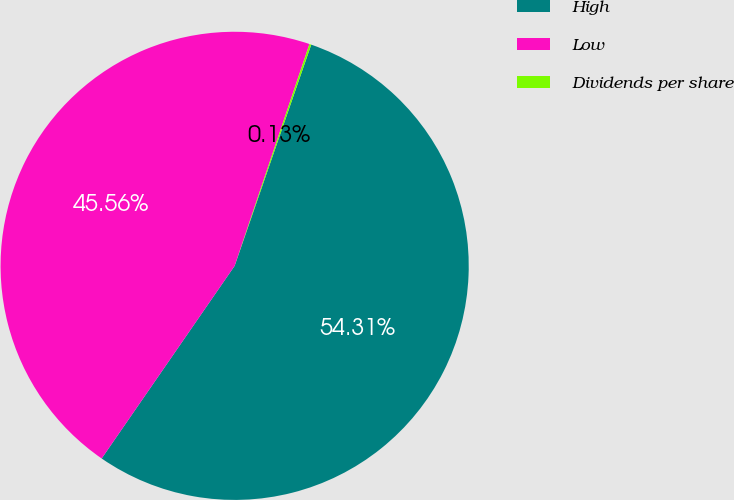<chart> <loc_0><loc_0><loc_500><loc_500><pie_chart><fcel>High<fcel>Low<fcel>Dividends per share<nl><fcel>54.31%<fcel>45.56%<fcel>0.13%<nl></chart> 